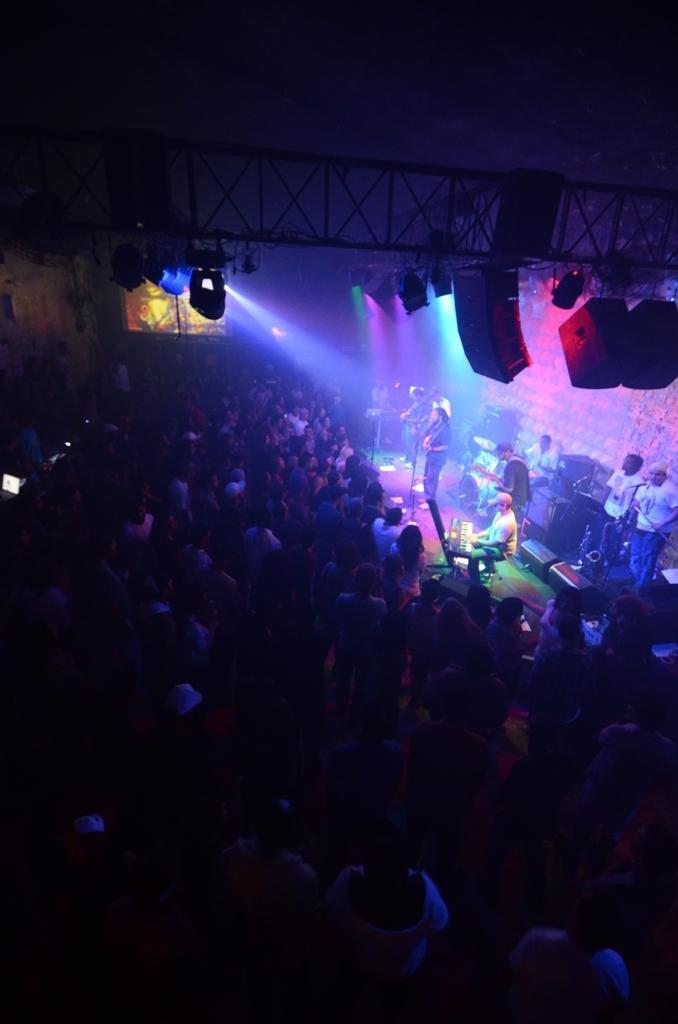Can you describe this image briefly? This looks like a stage show. There are groups of people standing. Here is a person playing the guitar. I can see another person sitting and playing the piano. I think these are the show lights, which are attached to the lighting truss. This looks like a wall. I can see few people playing the musical instruments. 